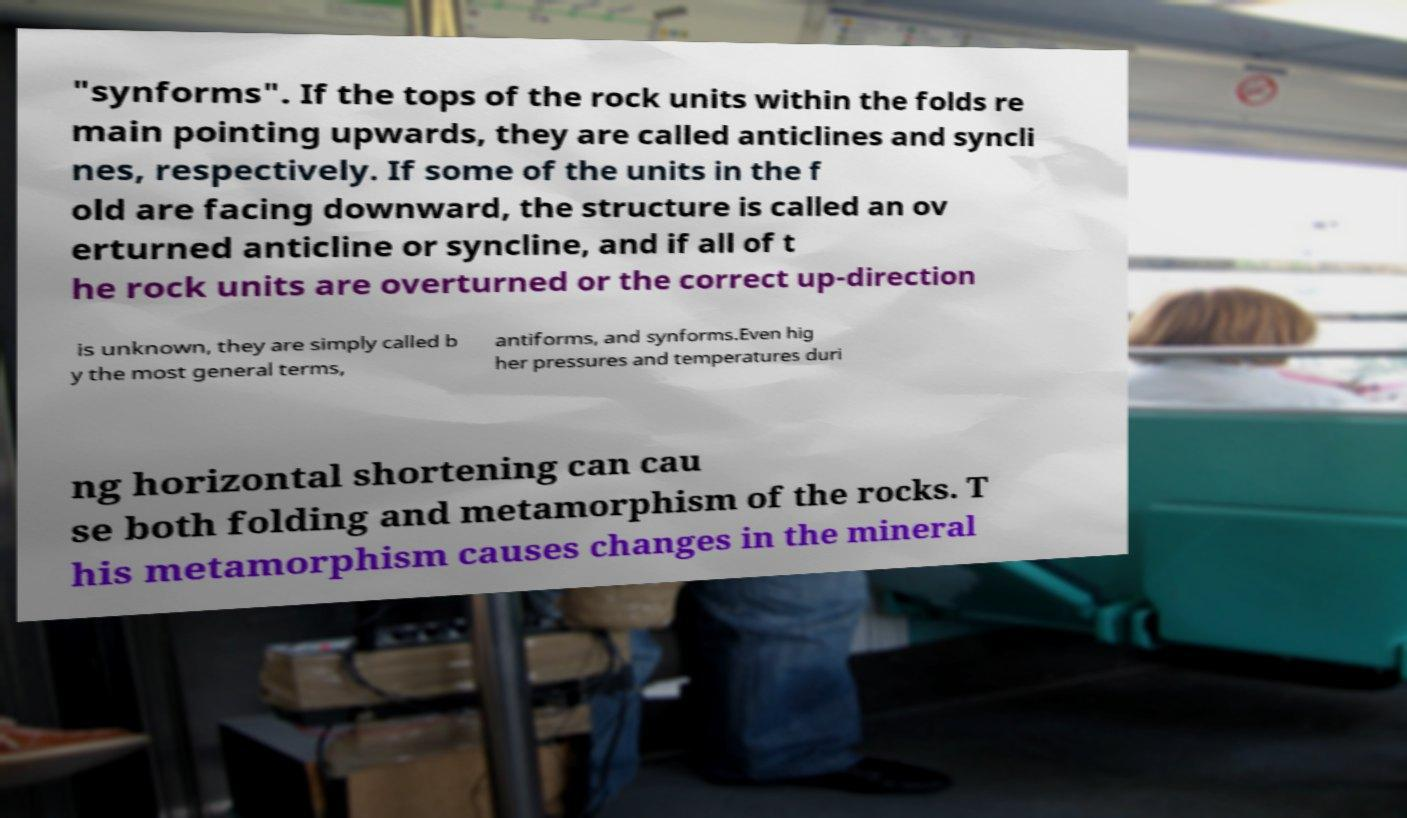Can you read and provide the text displayed in the image?This photo seems to have some interesting text. Can you extract and type it out for me? "synforms". If the tops of the rock units within the folds re main pointing upwards, they are called anticlines and syncli nes, respectively. If some of the units in the f old are facing downward, the structure is called an ov erturned anticline or syncline, and if all of t he rock units are overturned or the correct up-direction is unknown, they are simply called b y the most general terms, antiforms, and synforms.Even hig her pressures and temperatures duri ng horizontal shortening can cau se both folding and metamorphism of the rocks. T his metamorphism causes changes in the mineral 